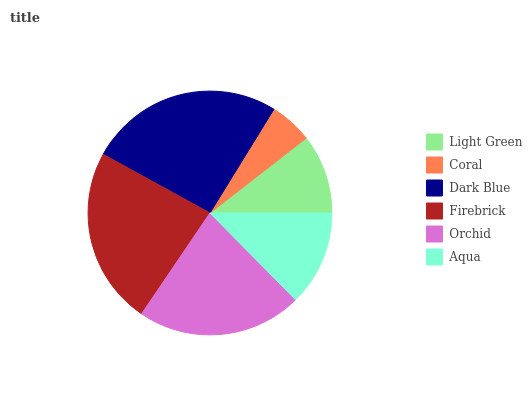Is Coral the minimum?
Answer yes or no. Yes. Is Dark Blue the maximum?
Answer yes or no. Yes. Is Dark Blue the minimum?
Answer yes or no. No. Is Coral the maximum?
Answer yes or no. No. Is Dark Blue greater than Coral?
Answer yes or no. Yes. Is Coral less than Dark Blue?
Answer yes or no. Yes. Is Coral greater than Dark Blue?
Answer yes or no. No. Is Dark Blue less than Coral?
Answer yes or no. No. Is Orchid the high median?
Answer yes or no. Yes. Is Aqua the low median?
Answer yes or no. Yes. Is Firebrick the high median?
Answer yes or no. No. Is Dark Blue the low median?
Answer yes or no. No. 